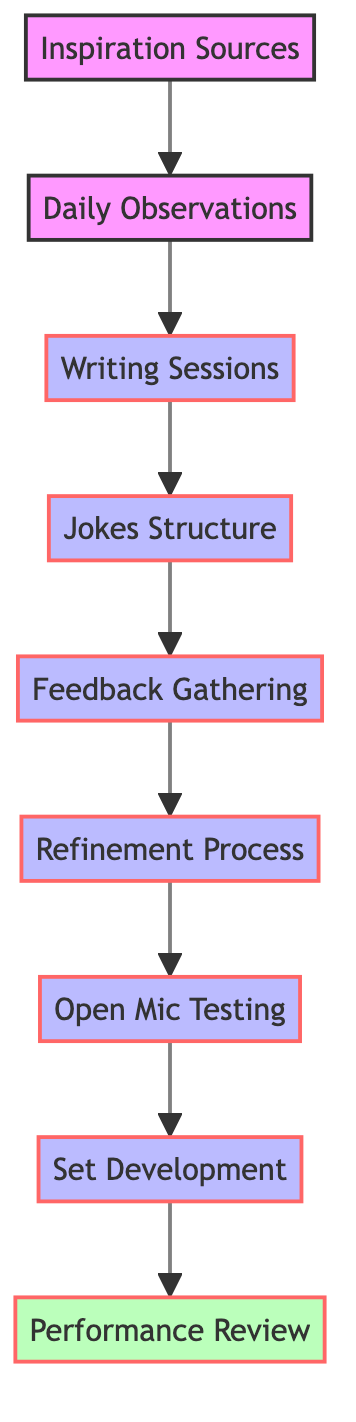What's the starting point of the comedy material development process? The diagram shows "Inspiration Sources" as the first node, indicating that it is the entry point for developing comedy material.
Answer: Inspiration Sources How many total nodes are in this diagram? The diagram contains nine nodes, as each unique element in the process is represented as a node.
Answer: Nine What node comes after "Daily Observations"? Following "Daily Observations," the next node in the flow is "Writing Sessions," indicating the sequential step in the comedy material development.
Answer: Writing Sessions Which step follows "Feedback Gathering"? The step that follows "Feedback Gathering" in the diagram is "Refinement Process," which suggests the importance of editing before further testing.
Answer: Refinement Process What is the last step in the comedy material development process? The final node in the diagram is "Performance Review," indicating the conclusion of the process after all preceding steps have been completed.
Answer: Performance Review Which node connects "Writing Sessions" to "Jokes Structure"? The directed edge from "Writing Sessions" leads directly to "Jokes Structure," showing the progression of the process from writing to structuring jokes.
Answer: Jokes Structure If you have completed "Open Mic Testing," what would be your next step? After "Open Mic Testing," the next logical step in the diagram is "Set Development," as it builds on feedback obtained from performance testing.
Answer: Set Development How many edges are there connecting the nodes in this diagram? The diagram consists of eight edges, which represent the direct connections between the sequential steps in the comedy material development process.
Answer: Eight What type of node is "Performance Review" categorized as? In the diagram, "Performance Review" is classified as a review node, distinguishing it from the other process nodes.
Answer: Review 